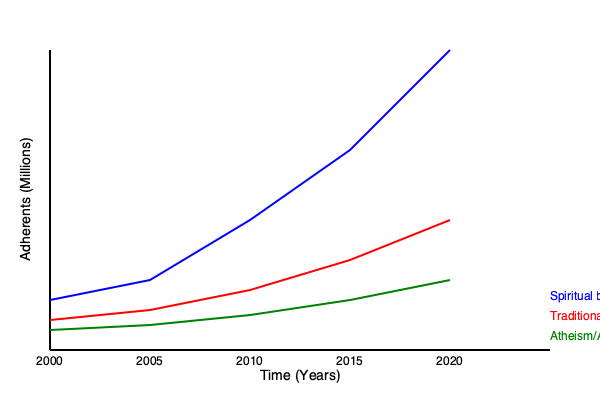Based on the line graph showing the growth rates of different spiritual practices from 2000 to 2020, calculate the average annual growth rate for the "Spiritual but not Religious" category. Express your answer as a percentage, rounded to two decimal places. To calculate the average annual growth rate for the "Spiritual but not Religious" category, we'll follow these steps:

1. Identify the initial and final values:
   Initial value (2000): Approximately 50 million
   Final value (2020): Approximately 300 million

2. Calculate the total growth factor:
   Growth factor = Final value / Initial value
   $\frac{300}{50} = 6$

3. Calculate the annual growth factor:
   Number of years = 20
   Annual growth factor = $\sqrt[20]{6}$

4. Convert to annual growth rate:
   Annual growth rate = (Annual growth factor - 1) × 100%

5. Use the formula:
   $r = (\sqrt[n]{\frac{Final}{Initial}} - 1) \times 100\%$
   Where $r$ is the average annual growth rate, $n$ is the number of years

6. Plug in the values:
   $r = (\sqrt[20]{\frac{300}{50}} - 1) \times 100\%$
   $r = (\sqrt[20]{6} - 1) \times 100\%$
   $r = (1.0954 - 1) \times 100\%$
   $r = 0.0954 \times 100\%$
   $r = 9.54\%$

Therefore, the average annual growth rate for the "Spiritual but not Religious" category is 9.54%.
Answer: 9.54% 